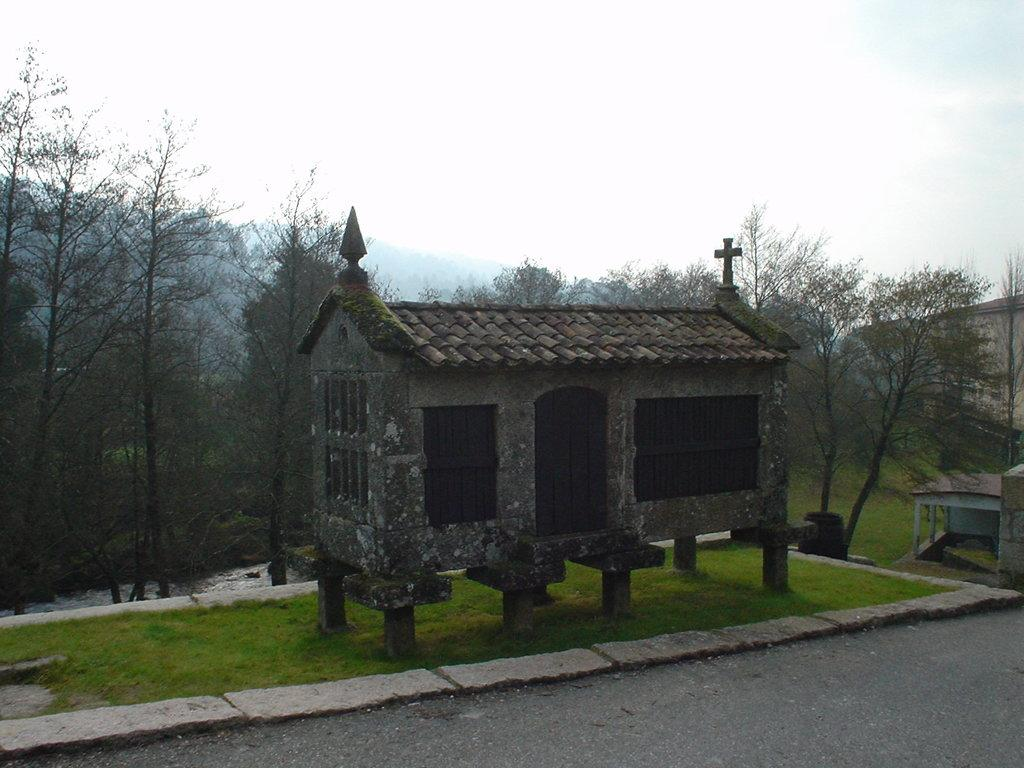What structure is located in the center of the image? There is a shed in the center of the image. What is at the bottom of the image? There is a road at the bottom of the image. What can be seen in the background of the image? There are trees and the sky visible in the background of the image. Where are the pigs located in the image? There are no pigs present in the image. What type of coach can be seen driving down the road in the image? There is no coach visible in the image; only a road is present at the bottom of the image. 